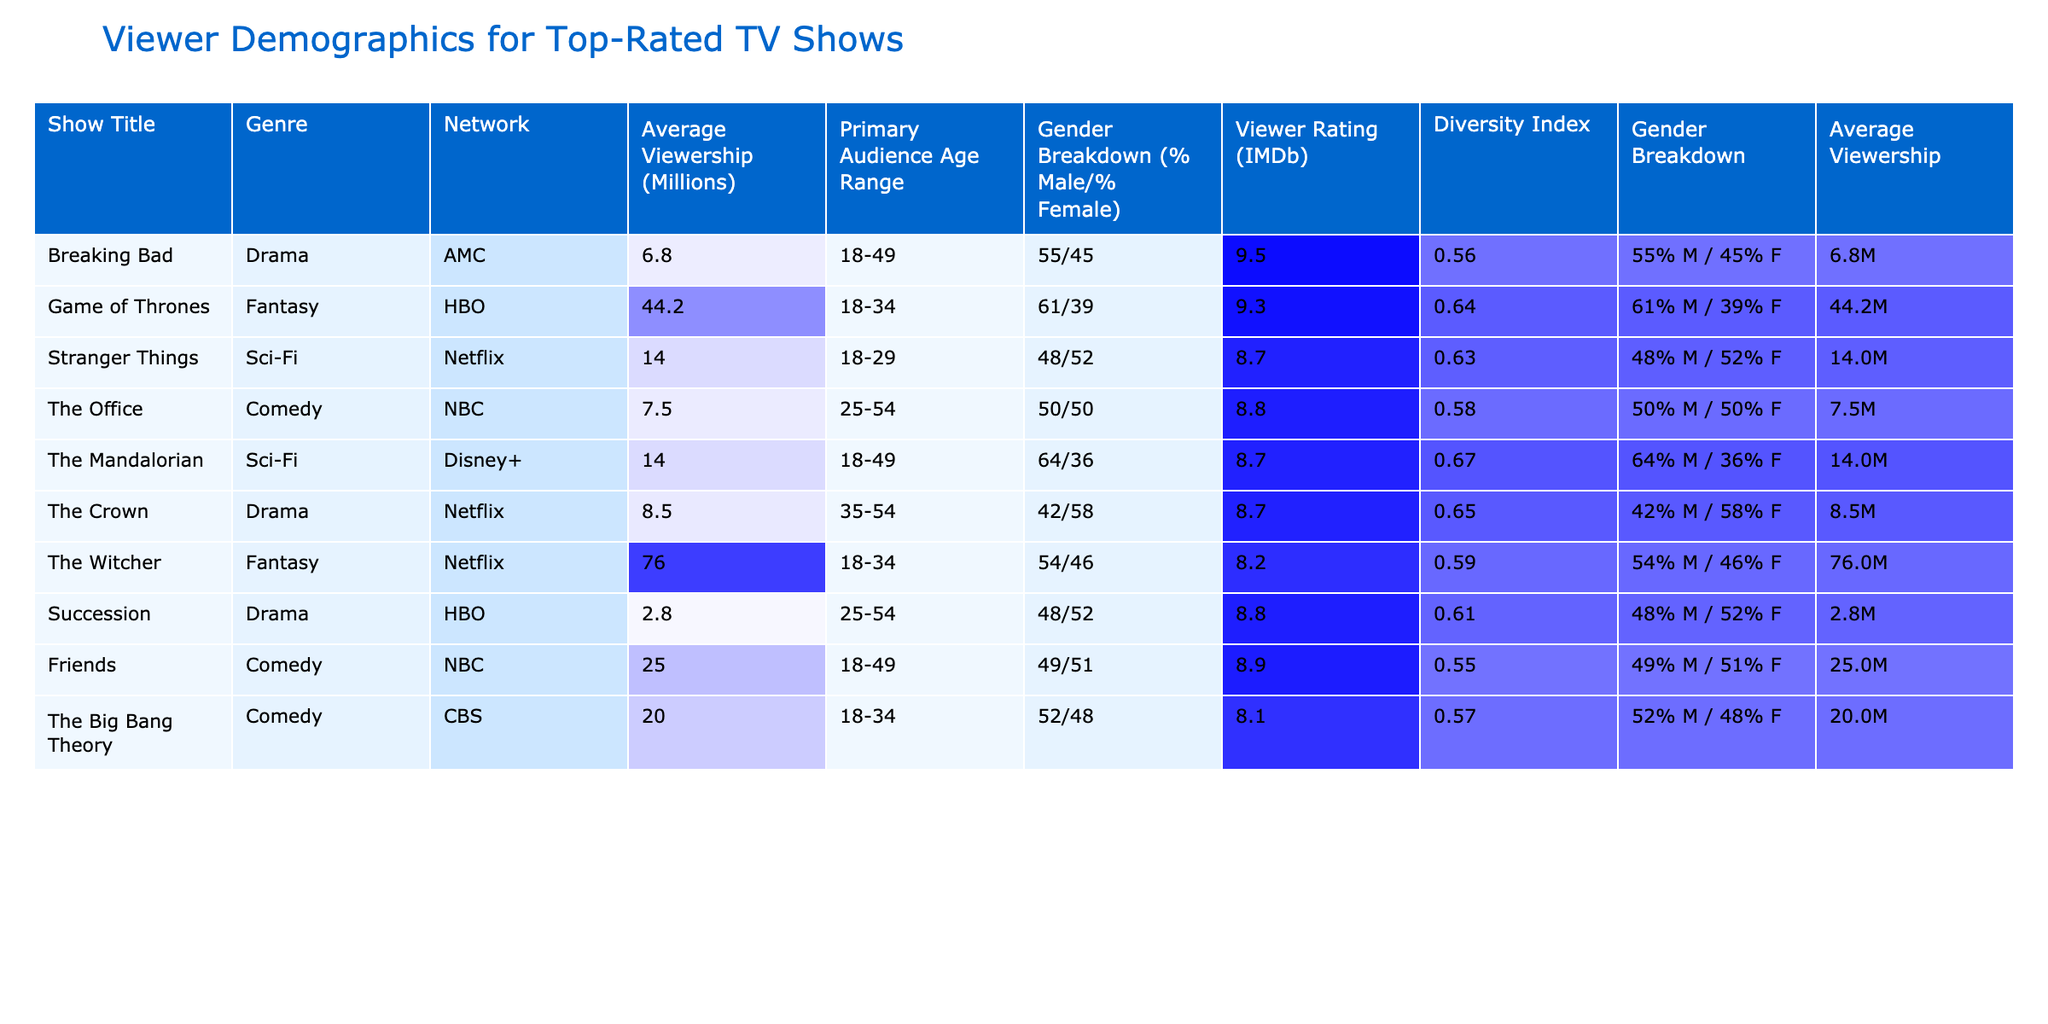What is the average viewership of "Game of Thrones"? The table lists "Game of Thrones" with an average viewership of 44.2 million.
Answer: 44.2 million Which show has the highest Viewer Rating on IMDb? According to the table, "Breaking Bad" has the highest IMDb rating of 9.5.
Answer: Breaking Bad What percentage of the audience for "The Mandalorian" is male? The gender breakdown for "The Mandalorian" is 64% male, as shown in the table.
Answer: 64% Is the average viewership for "Stranger Things" greater than that of "The Office"? "Stranger Things" has an average viewership of 14 million while "The Office" has 7.5 million, so the average viewership of "Stranger Things" is greater.
Answer: Yes What is the average diversity index for all shows listed? The diversity indexes for the shows are 0.56, 0.64, 0.63, 0.58, 0.67, 0.65, 0.59, 0.61, and 0.55. Summing these gives 5.34, and dividing by 9 shows an average of 0.5933 (rounded to 0.59).
Answer: 0.59 How does the diversity index of "The Witcher" compare to "Friends"? "The Witcher" has a diversity index of 0.59 while "Friends" has 0.55. Since 0.59 is greater than 0.55, "The Witcher" has a higher diversity index.
Answer: Higher What is the average viewership of shows in the 'Comedy' genre? The average viewership for comedies are: "The Office" (7.5M), "Friends" (25M), and "The Big Bang Theory" (20M). Summing these values results in 52.5 million, and dividing by 3 gives an average viewership of 17.5 million.
Answer: 17.5 million Which network has the most shows represented in the table? The table shows "AMC", "HBO", "Netflix", "NBC", and "CBS" as networks, with Netflix having 3 shows ("Stranger Things", "The Crown", and "The Witcher"), which is the highest.
Answer: Netflix Do more than half of the shows have a viewer rating on IMDb higher than 8.5? The IMDb ratings higher than 8.5 are "Breaking Bad" (9.5), "Game of Thrones" (9.3), "The Office" (8.8), "Friends" (8.9), and "Succession" (8.8). This totals to 5 out of 9, which is more than half.
Answer: Yes Which show has the lowest average viewership, and what is that number? "Succession" has the lowest average viewership at 2.8 million according to the table.
Answer: 2.8 million 